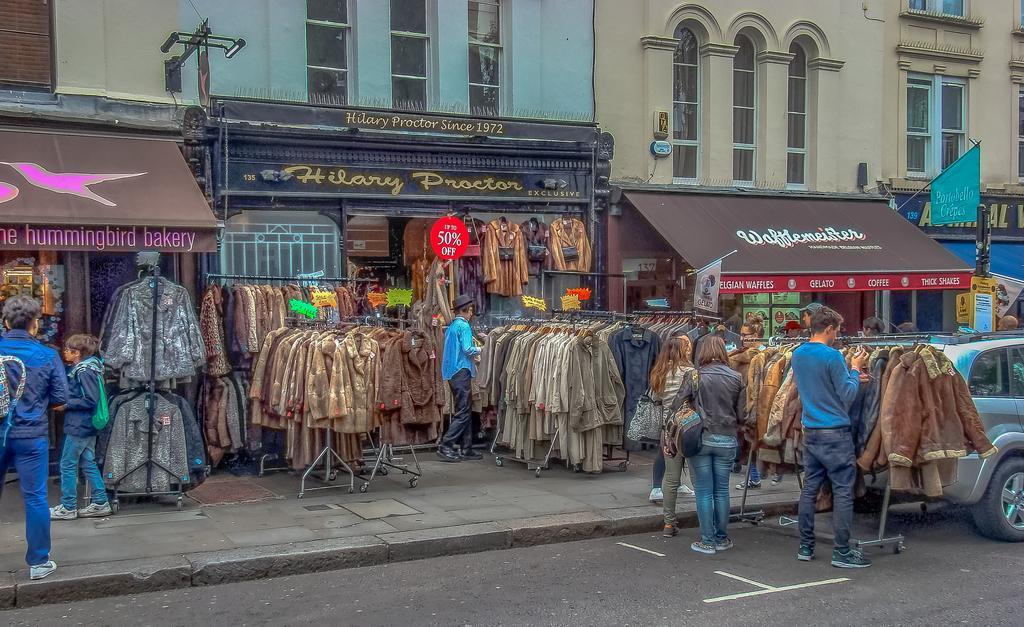Please provide a concise description of this image. In this picture there are stalls in the center. Before the stalls, there are jackets hanged to the holders. There is a man towards the right wearing a blue t shirt and checking the jackets, beside him there are two woman. In the center there is a man in blue shirt and a black hat. Towards the left there are two persons. At the bottom there is a road. Towards the right corner, there is a vehicle. 